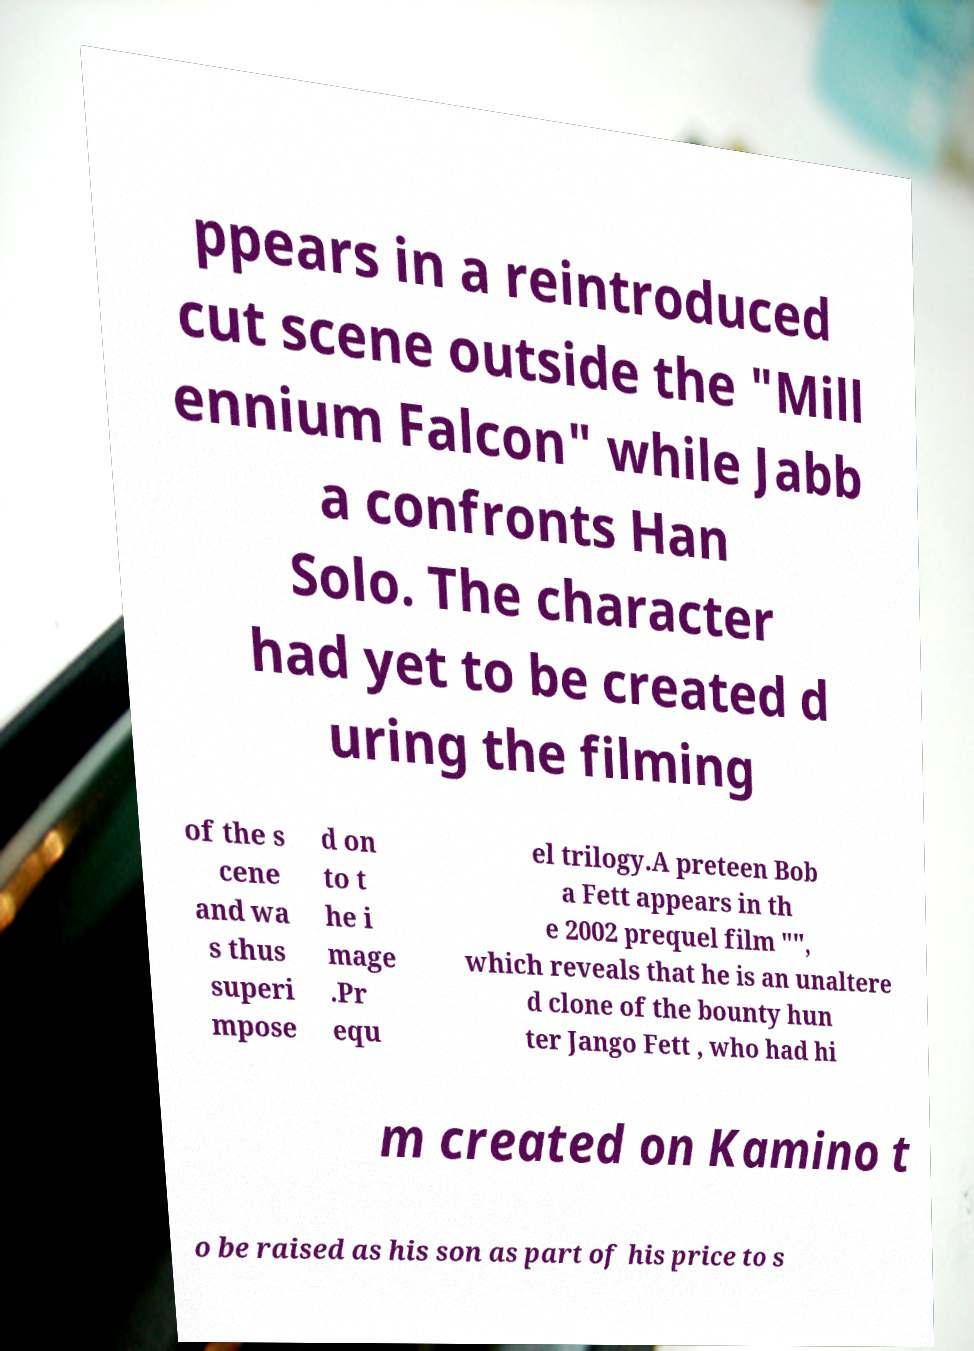What messages or text are displayed in this image? I need them in a readable, typed format. ppears in a reintroduced cut scene outside the "Mill ennium Falcon" while Jabb a confronts Han Solo. The character had yet to be created d uring the filming of the s cene and wa s thus superi mpose d on to t he i mage .Pr equ el trilogy.A preteen Bob a Fett appears in th e 2002 prequel film "", which reveals that he is an unaltere d clone of the bounty hun ter Jango Fett , who had hi m created on Kamino t o be raised as his son as part of his price to s 